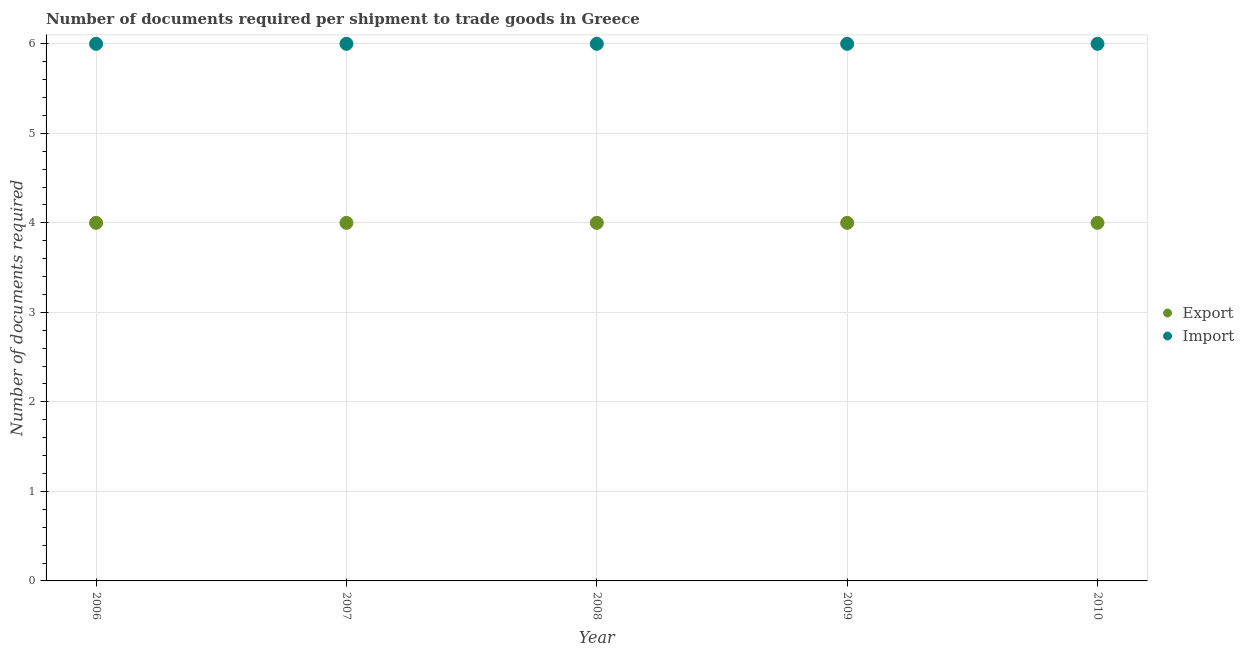Is the number of dotlines equal to the number of legend labels?
Keep it short and to the point. Yes. What is the number of documents required to export goods in 2010?
Provide a succinct answer. 4. Across all years, what is the maximum number of documents required to import goods?
Offer a terse response. 6. What is the total number of documents required to import goods in the graph?
Provide a short and direct response. 30. What is the difference between the number of documents required to export goods in 2007 and that in 2008?
Provide a short and direct response. 0. What is the difference between the number of documents required to import goods in 2007 and the number of documents required to export goods in 2010?
Your answer should be very brief. 2. What is the average number of documents required to import goods per year?
Offer a terse response. 6. In the year 2007, what is the difference between the number of documents required to import goods and number of documents required to export goods?
Ensure brevity in your answer.  2. Is the number of documents required to import goods in 2007 less than that in 2009?
Ensure brevity in your answer.  No. Is the difference between the number of documents required to import goods in 2006 and 2010 greater than the difference between the number of documents required to export goods in 2006 and 2010?
Your response must be concise. No. What is the difference between the highest and the second highest number of documents required to import goods?
Offer a terse response. 0. What is the difference between the highest and the lowest number of documents required to export goods?
Offer a very short reply. 0. In how many years, is the number of documents required to export goods greater than the average number of documents required to export goods taken over all years?
Provide a short and direct response. 0. Is the sum of the number of documents required to import goods in 2007 and 2009 greater than the maximum number of documents required to export goods across all years?
Your answer should be very brief. Yes. Does the number of documents required to import goods monotonically increase over the years?
Provide a succinct answer. No. Does the graph contain any zero values?
Your response must be concise. No. Where does the legend appear in the graph?
Ensure brevity in your answer.  Center right. How many legend labels are there?
Keep it short and to the point. 2. How are the legend labels stacked?
Give a very brief answer. Vertical. What is the title of the graph?
Keep it short and to the point. Number of documents required per shipment to trade goods in Greece. What is the label or title of the Y-axis?
Your answer should be compact. Number of documents required. What is the Number of documents required in Export in 2006?
Offer a very short reply. 4. What is the Number of documents required in Import in 2006?
Keep it short and to the point. 6. What is the Number of documents required in Import in 2007?
Your answer should be compact. 6. What is the Number of documents required of Export in 2009?
Offer a very short reply. 4. What is the Number of documents required of Import in 2009?
Keep it short and to the point. 6. What is the Number of documents required of Export in 2010?
Keep it short and to the point. 4. What is the Number of documents required of Import in 2010?
Ensure brevity in your answer.  6. Across all years, what is the maximum Number of documents required of Export?
Your response must be concise. 4. Across all years, what is the maximum Number of documents required of Import?
Provide a succinct answer. 6. Across all years, what is the minimum Number of documents required of Export?
Your response must be concise. 4. Across all years, what is the minimum Number of documents required of Import?
Your answer should be very brief. 6. What is the total Number of documents required of Export in the graph?
Ensure brevity in your answer.  20. What is the difference between the Number of documents required of Export in 2006 and that in 2007?
Your answer should be compact. 0. What is the difference between the Number of documents required in Import in 2006 and that in 2007?
Offer a terse response. 0. What is the difference between the Number of documents required of Export in 2006 and that in 2010?
Your response must be concise. 0. What is the difference between the Number of documents required in Import in 2007 and that in 2008?
Ensure brevity in your answer.  0. What is the difference between the Number of documents required in Export in 2007 and that in 2009?
Give a very brief answer. 0. What is the difference between the Number of documents required of Import in 2007 and that in 2009?
Offer a very short reply. 0. What is the difference between the Number of documents required in Import in 2007 and that in 2010?
Your answer should be very brief. 0. What is the difference between the Number of documents required of Export in 2008 and that in 2010?
Your response must be concise. 0. What is the difference between the Number of documents required of Export in 2009 and that in 2010?
Make the answer very short. 0. What is the difference between the Number of documents required in Import in 2009 and that in 2010?
Make the answer very short. 0. What is the difference between the Number of documents required of Export in 2006 and the Number of documents required of Import in 2007?
Provide a succinct answer. -2. What is the difference between the Number of documents required of Export in 2006 and the Number of documents required of Import in 2010?
Your answer should be compact. -2. What is the difference between the Number of documents required of Export in 2007 and the Number of documents required of Import in 2008?
Provide a succinct answer. -2. What is the difference between the Number of documents required in Export in 2008 and the Number of documents required in Import in 2009?
Your answer should be very brief. -2. What is the difference between the Number of documents required in Export in 2009 and the Number of documents required in Import in 2010?
Provide a succinct answer. -2. What is the average Number of documents required in Import per year?
Give a very brief answer. 6. In the year 2008, what is the difference between the Number of documents required in Export and Number of documents required in Import?
Your answer should be very brief. -2. What is the ratio of the Number of documents required in Import in 2006 to that in 2007?
Your answer should be very brief. 1. What is the ratio of the Number of documents required of Export in 2006 to that in 2008?
Your answer should be compact. 1. What is the ratio of the Number of documents required of Export in 2006 to that in 2009?
Provide a succinct answer. 1. What is the ratio of the Number of documents required of Export in 2007 to that in 2008?
Offer a terse response. 1. What is the ratio of the Number of documents required of Import in 2007 to that in 2009?
Provide a short and direct response. 1. What is the ratio of the Number of documents required in Import in 2007 to that in 2010?
Offer a terse response. 1. What is the ratio of the Number of documents required of Export in 2008 to that in 2009?
Provide a succinct answer. 1. What is the ratio of the Number of documents required in Import in 2008 to that in 2009?
Provide a short and direct response. 1. What is the ratio of the Number of documents required of Import in 2008 to that in 2010?
Your response must be concise. 1. What is the ratio of the Number of documents required in Export in 2009 to that in 2010?
Offer a very short reply. 1. What is the ratio of the Number of documents required of Import in 2009 to that in 2010?
Your answer should be very brief. 1. What is the difference between the highest and the second highest Number of documents required in Import?
Provide a short and direct response. 0. What is the difference between the highest and the lowest Number of documents required of Import?
Keep it short and to the point. 0. 